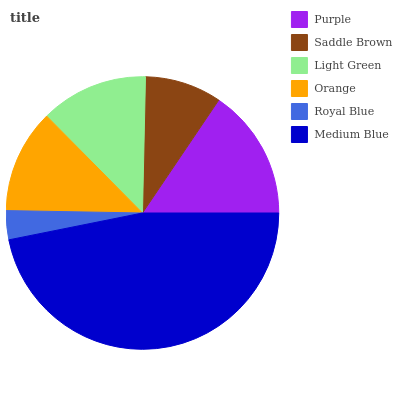Is Royal Blue the minimum?
Answer yes or no. Yes. Is Medium Blue the maximum?
Answer yes or no. Yes. Is Saddle Brown the minimum?
Answer yes or no. No. Is Saddle Brown the maximum?
Answer yes or no. No. Is Purple greater than Saddle Brown?
Answer yes or no. Yes. Is Saddle Brown less than Purple?
Answer yes or no. Yes. Is Saddle Brown greater than Purple?
Answer yes or no. No. Is Purple less than Saddle Brown?
Answer yes or no. No. Is Light Green the high median?
Answer yes or no. Yes. Is Orange the low median?
Answer yes or no. Yes. Is Purple the high median?
Answer yes or no. No. Is Medium Blue the low median?
Answer yes or no. No. 